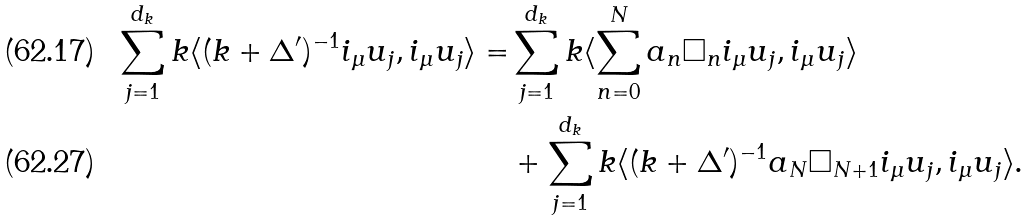<formula> <loc_0><loc_0><loc_500><loc_500>\sum _ { j = 1 } ^ { d _ { k } } k \langle ( k + \Delta ^ { \prime } ) ^ { - 1 } i _ { \mu } u _ { j } , i _ { \mu } u _ { j } \rangle = & \sum _ { j = 1 } ^ { d _ { k } } k \langle \sum _ { n = 0 } ^ { N } a _ { n } \square _ { n } i _ { \mu } u _ { j } , i _ { \mu } u _ { j } \rangle \\ & + \sum _ { j = 1 } ^ { d _ { k } } k \langle ( k + \Delta ^ { \prime } ) ^ { - 1 } a _ { N } \square _ { N + 1 } i _ { \mu } u _ { j } , i _ { \mu } u _ { j } \rangle .</formula> 